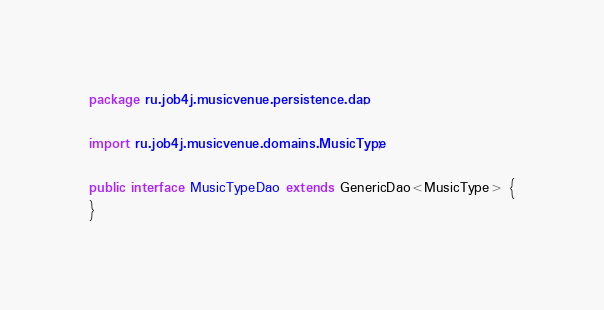<code> <loc_0><loc_0><loc_500><loc_500><_Java_>package ru.job4j.musicvenue.persistence.dao;

import ru.job4j.musicvenue.domains.MusicType;

public interface MusicTypeDao extends GenericDao<MusicType> {
}
</code> 